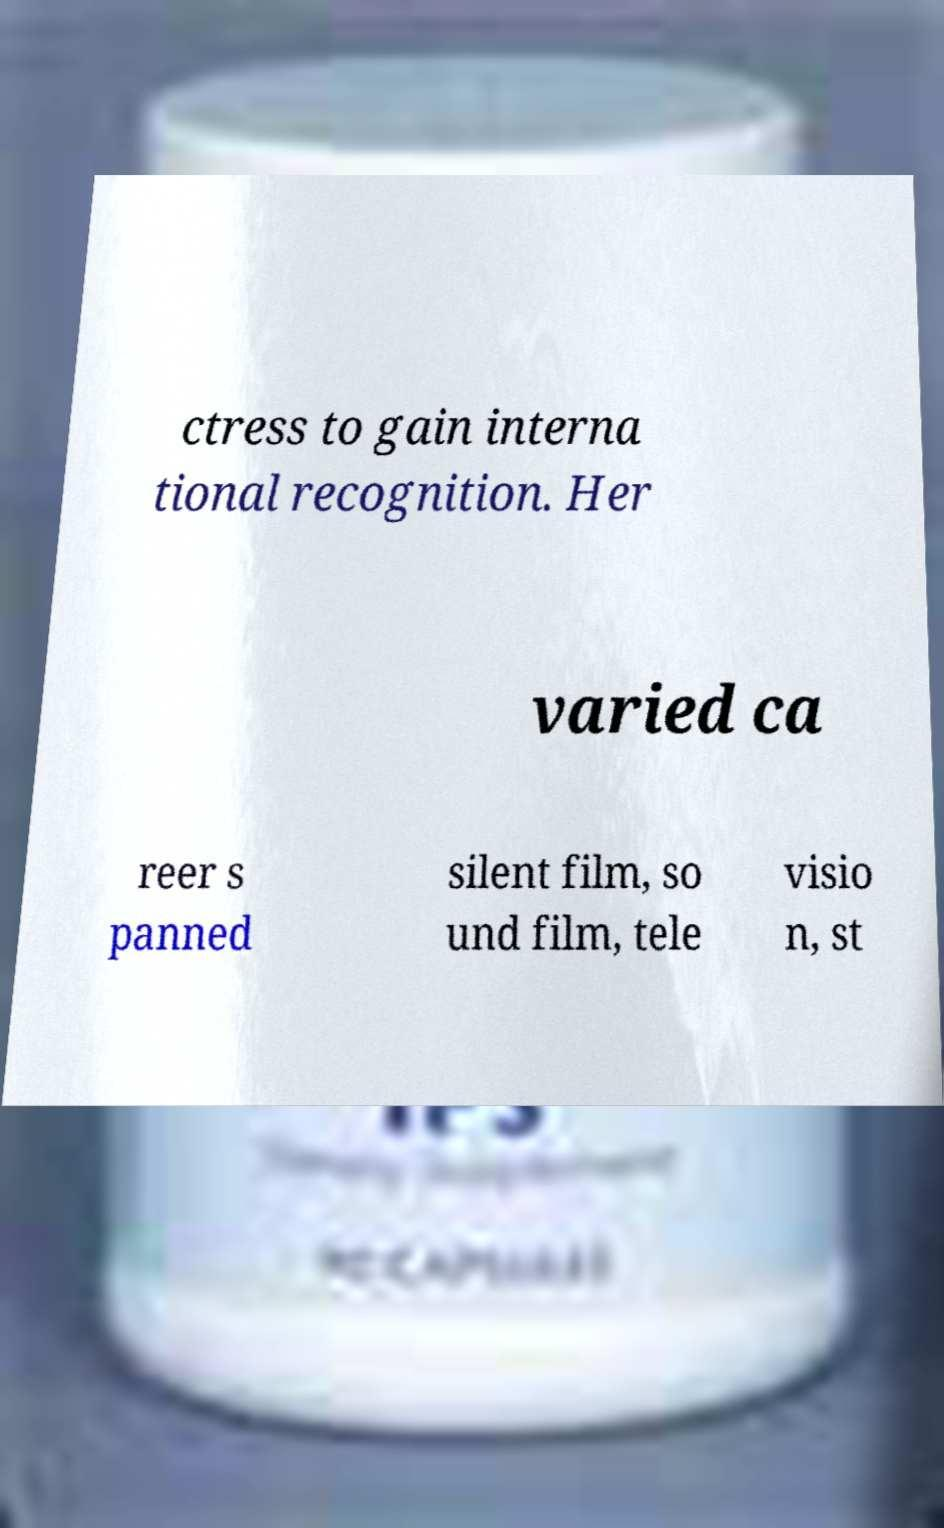There's text embedded in this image that I need extracted. Can you transcribe it verbatim? ctress to gain interna tional recognition. Her varied ca reer s panned silent film, so und film, tele visio n, st 